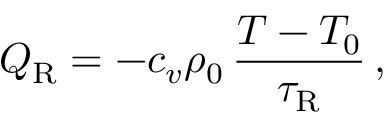Convert formula to latex. <formula><loc_0><loc_0><loc_500><loc_500>Q _ { R } = - c _ { v } \rho _ { 0 } \, \frac { T - T _ { 0 } } { \tau _ { R } } \, ,</formula> 